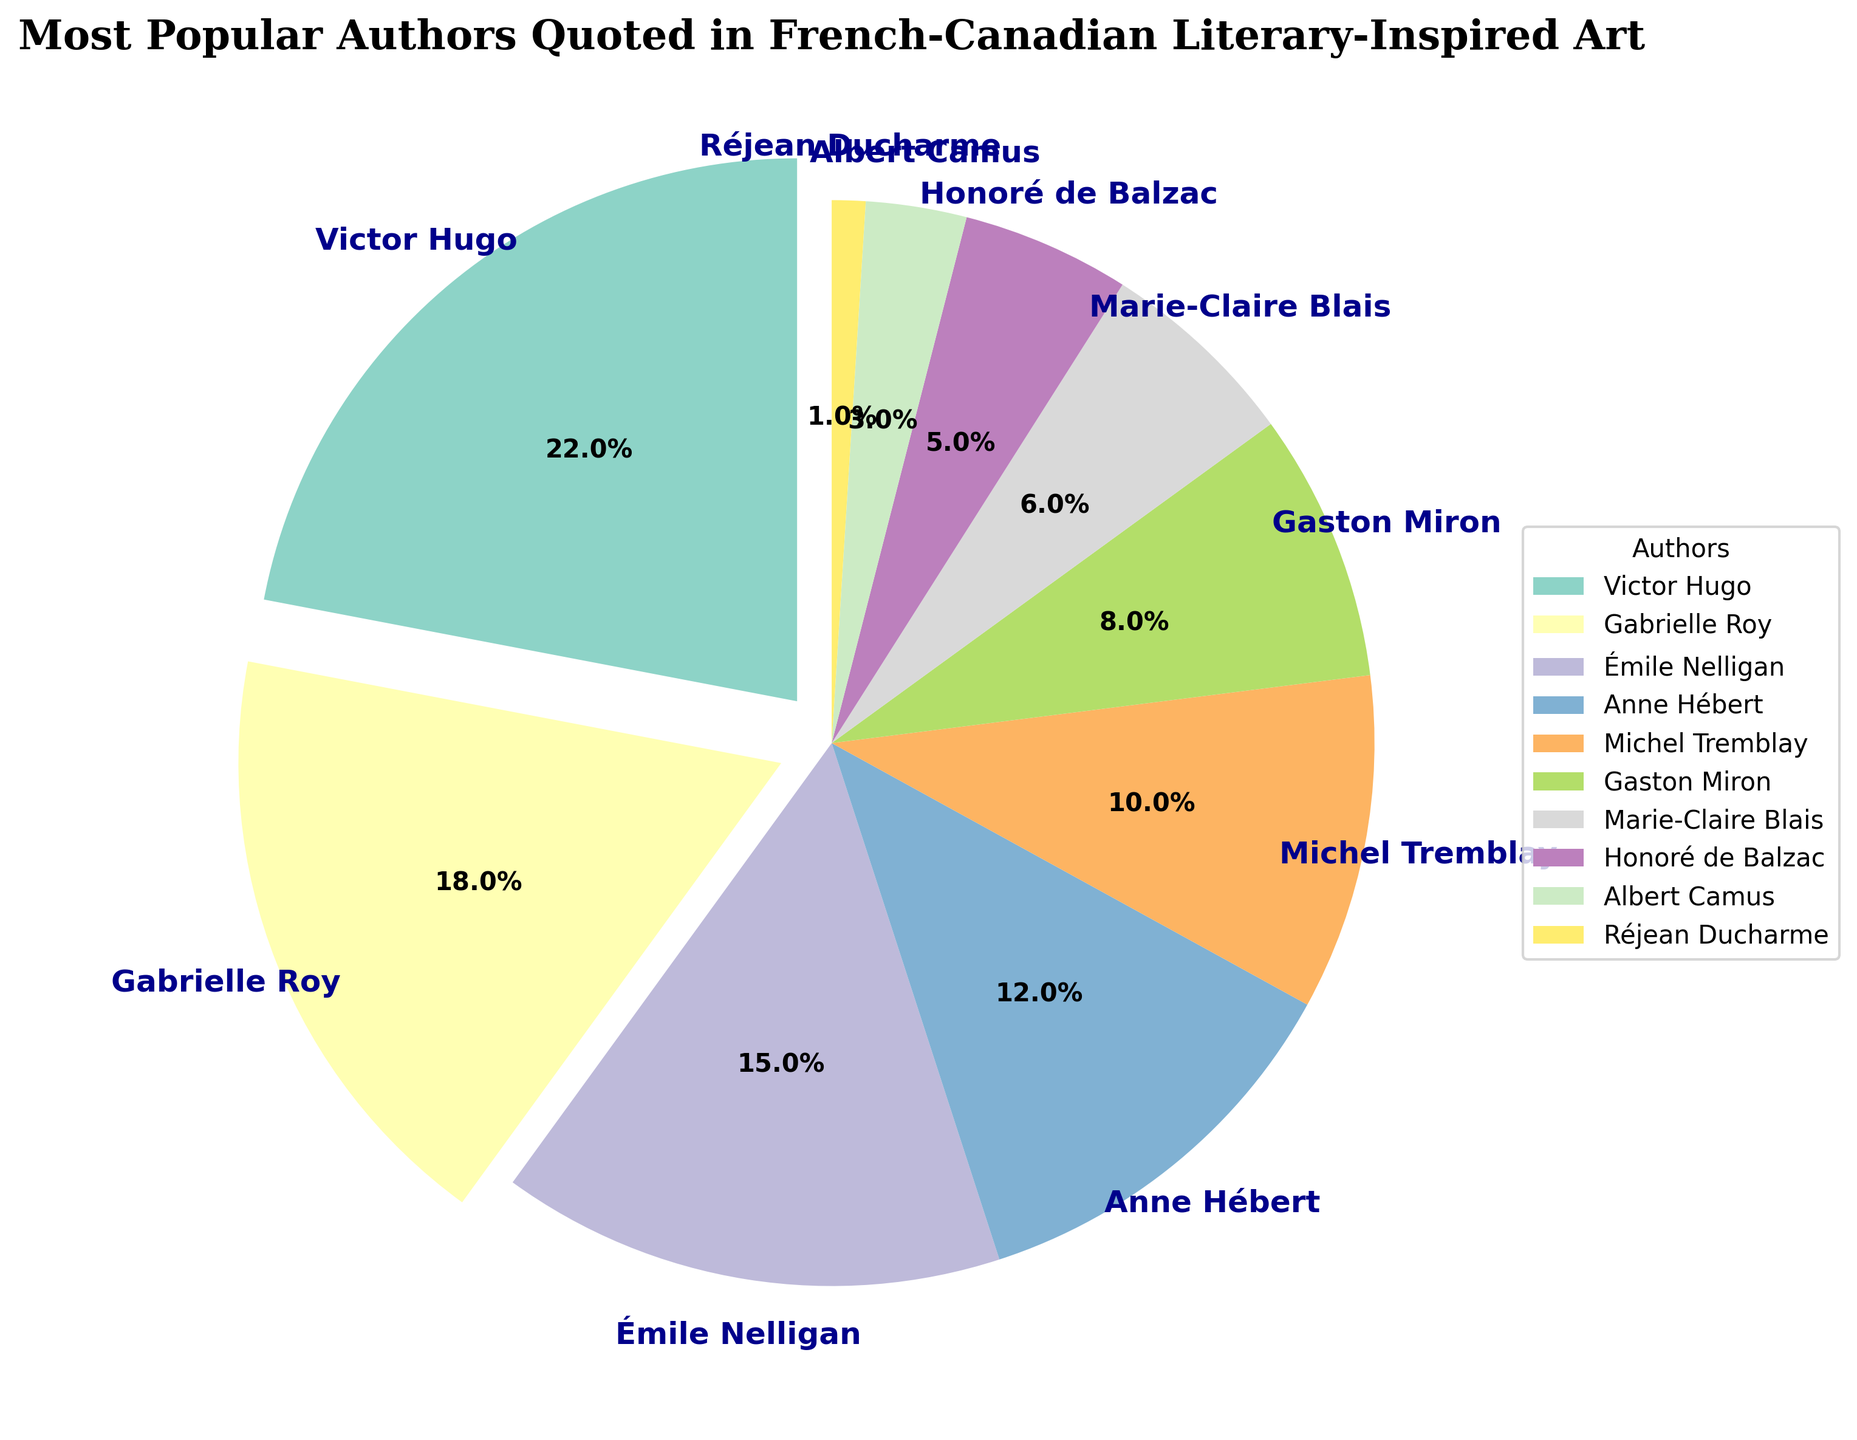Which author has the highest percentage of quotes? The author with the largest wedge in the pie chart, indicated by both size and a segment exploded outwards, is depicted.
Answer: Victor Hugo Which authors together make up more than half of the quotes? Adding the percentages of the authors from largest to smallest. Victor Hugo (22%) + Gabrielle Roy (18%) + Émile Nelligan (15%) = 55%. These three authors collectively exceed 50%.
Answer: Victor Hugo, Gabrielle Roy, and Émile Nelligan How does the percentage of quotes from Anne Hébert compare to Michel Tremblay? Comparing the wedges labeled Anne Hébert (12%) and Michel Tremblay (10%).
Answer: Anne Hébert has a higher percentage What is the combined percentage of quotes from Michel Tremblay and Gaston Miron? Adding the percentages for Michel Tremblay (10%) and Gaston Miron (8%).
Answer: 18% What percentage of quotes are from the authors ranked fifth and below in the chart? Summing the percentages of Michel Tremblay (10%), Gaston Miron (8%), Marie-Claire Blais (6%), Honoré de Balzac (5%), Albert Camus (3%), and Réjean Ducharme (1%).
Answer: 33% Which quadrant does the wedge representing Gabrielle Roy fall into? Observing the starting angle and position of the wedge for Gabrielle Roy (18%) relative to the entire pie chart.
Answer: First quadrant Who is quoted least frequently in French-Canadian literary-inspired art? The author with the smallest wedge in the pie chart, as indicated by the labels and percentage.
Answer: Réjean Ducharme Is the combined percentage of quotes from Émile Nelligan, Anne Hébert, and Michel Tremblay greater than the number of quotes from Victor Hugo? Adding the percentages for Émile Nelligan (15%), Anne Hébert (12%), and Michel Tremblay (10%) which equals 37%, and comparing it to Victor Hugo's 22%.
Answer: Yes 